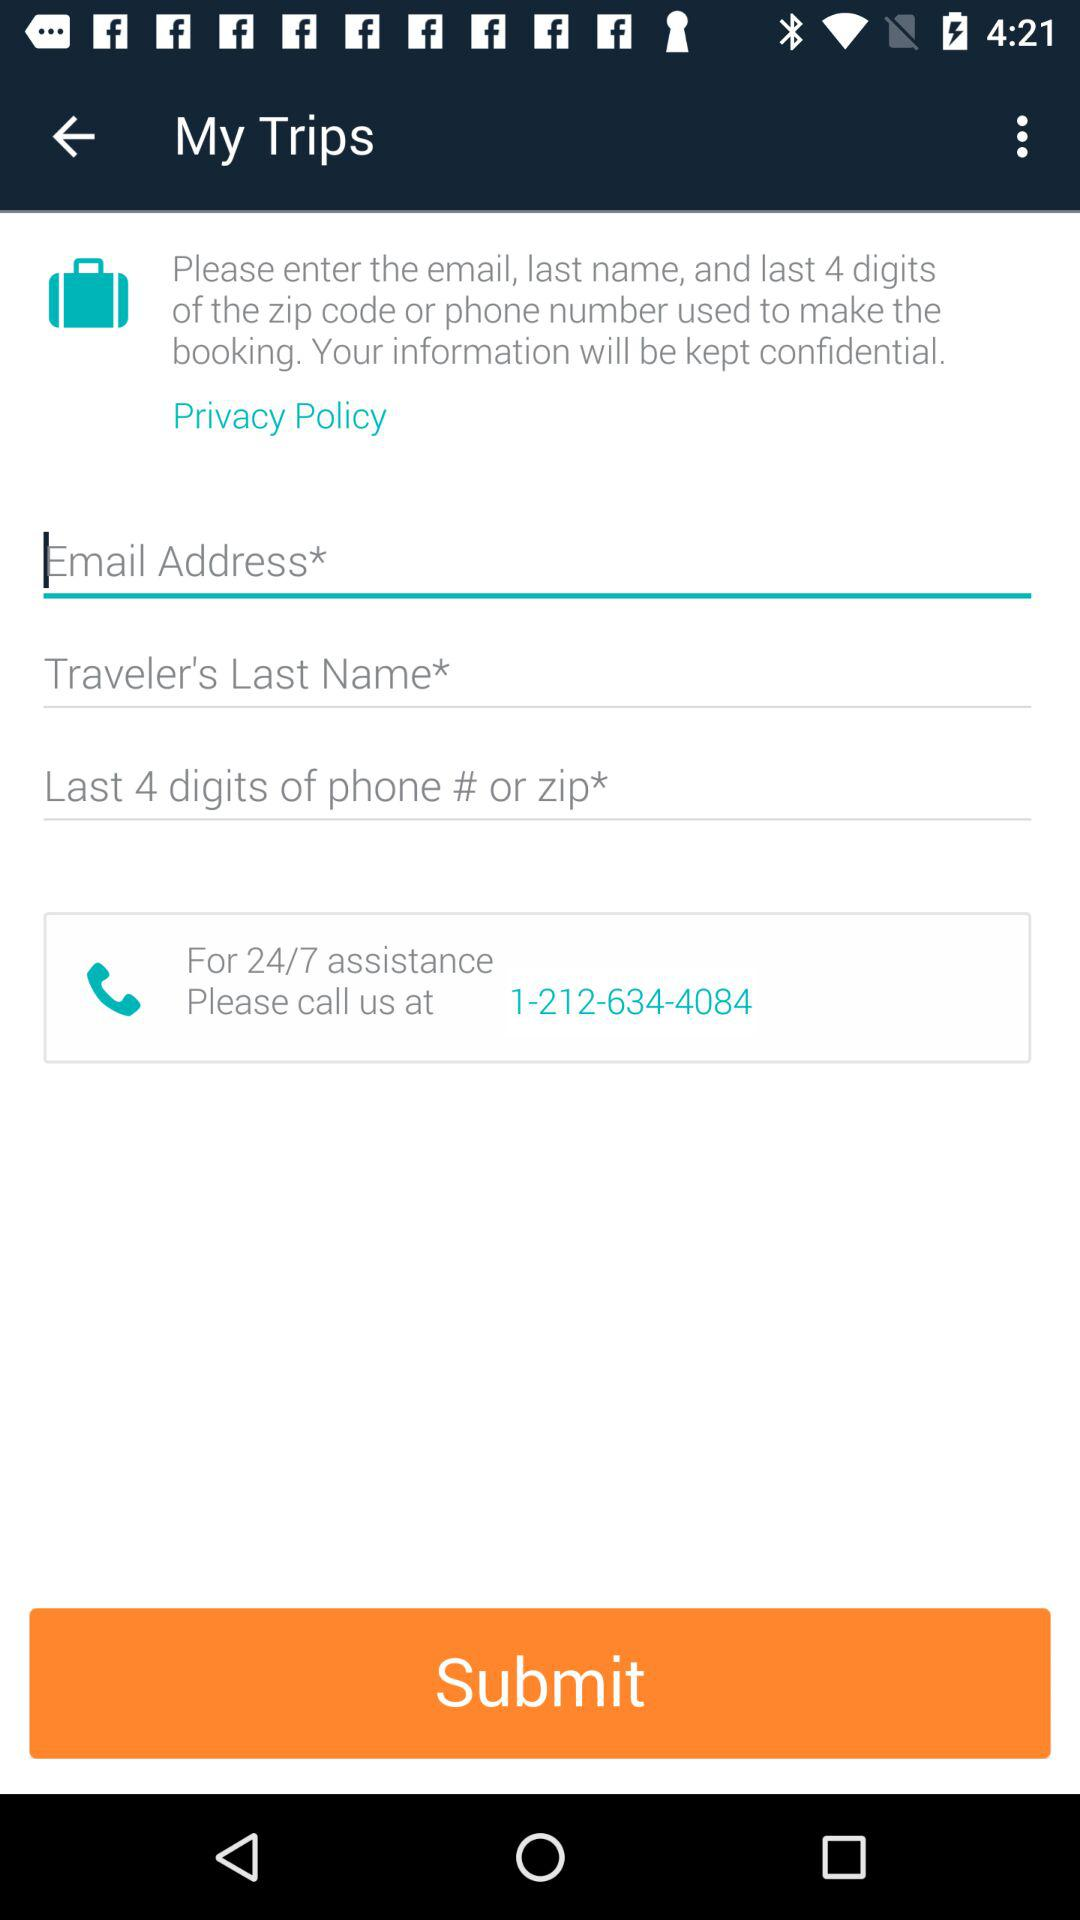What is the phone number? The phone number is 1-212-634-4084. 